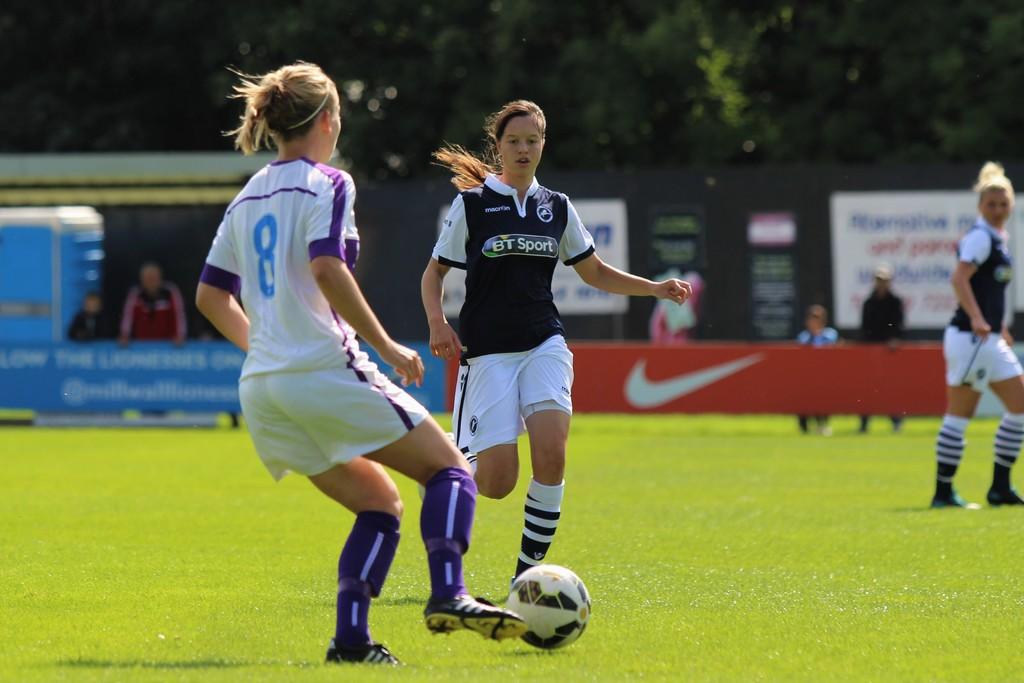What jersey number is worn by the person in white?
Offer a terse response. 8. What word is visible on the black jersey?
Keep it short and to the point. Sport. 